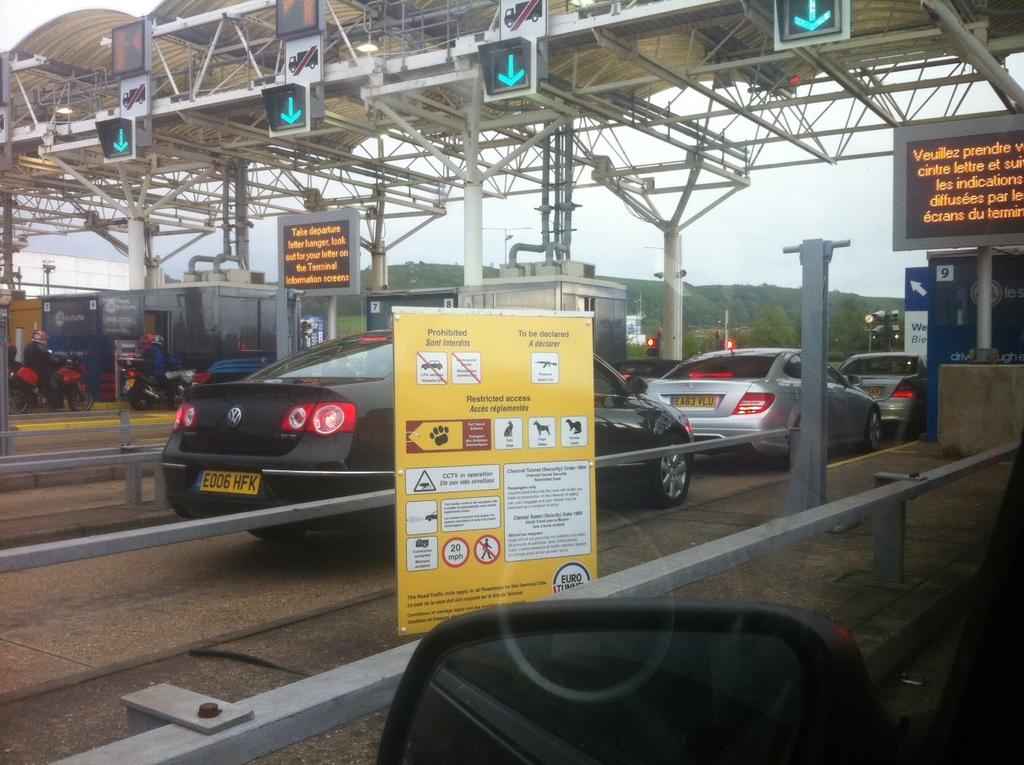What does the yellow sign advise?
Make the answer very short. Restricted access. What is the license plate of the vw?
Your answer should be very brief. E006 hfk. 